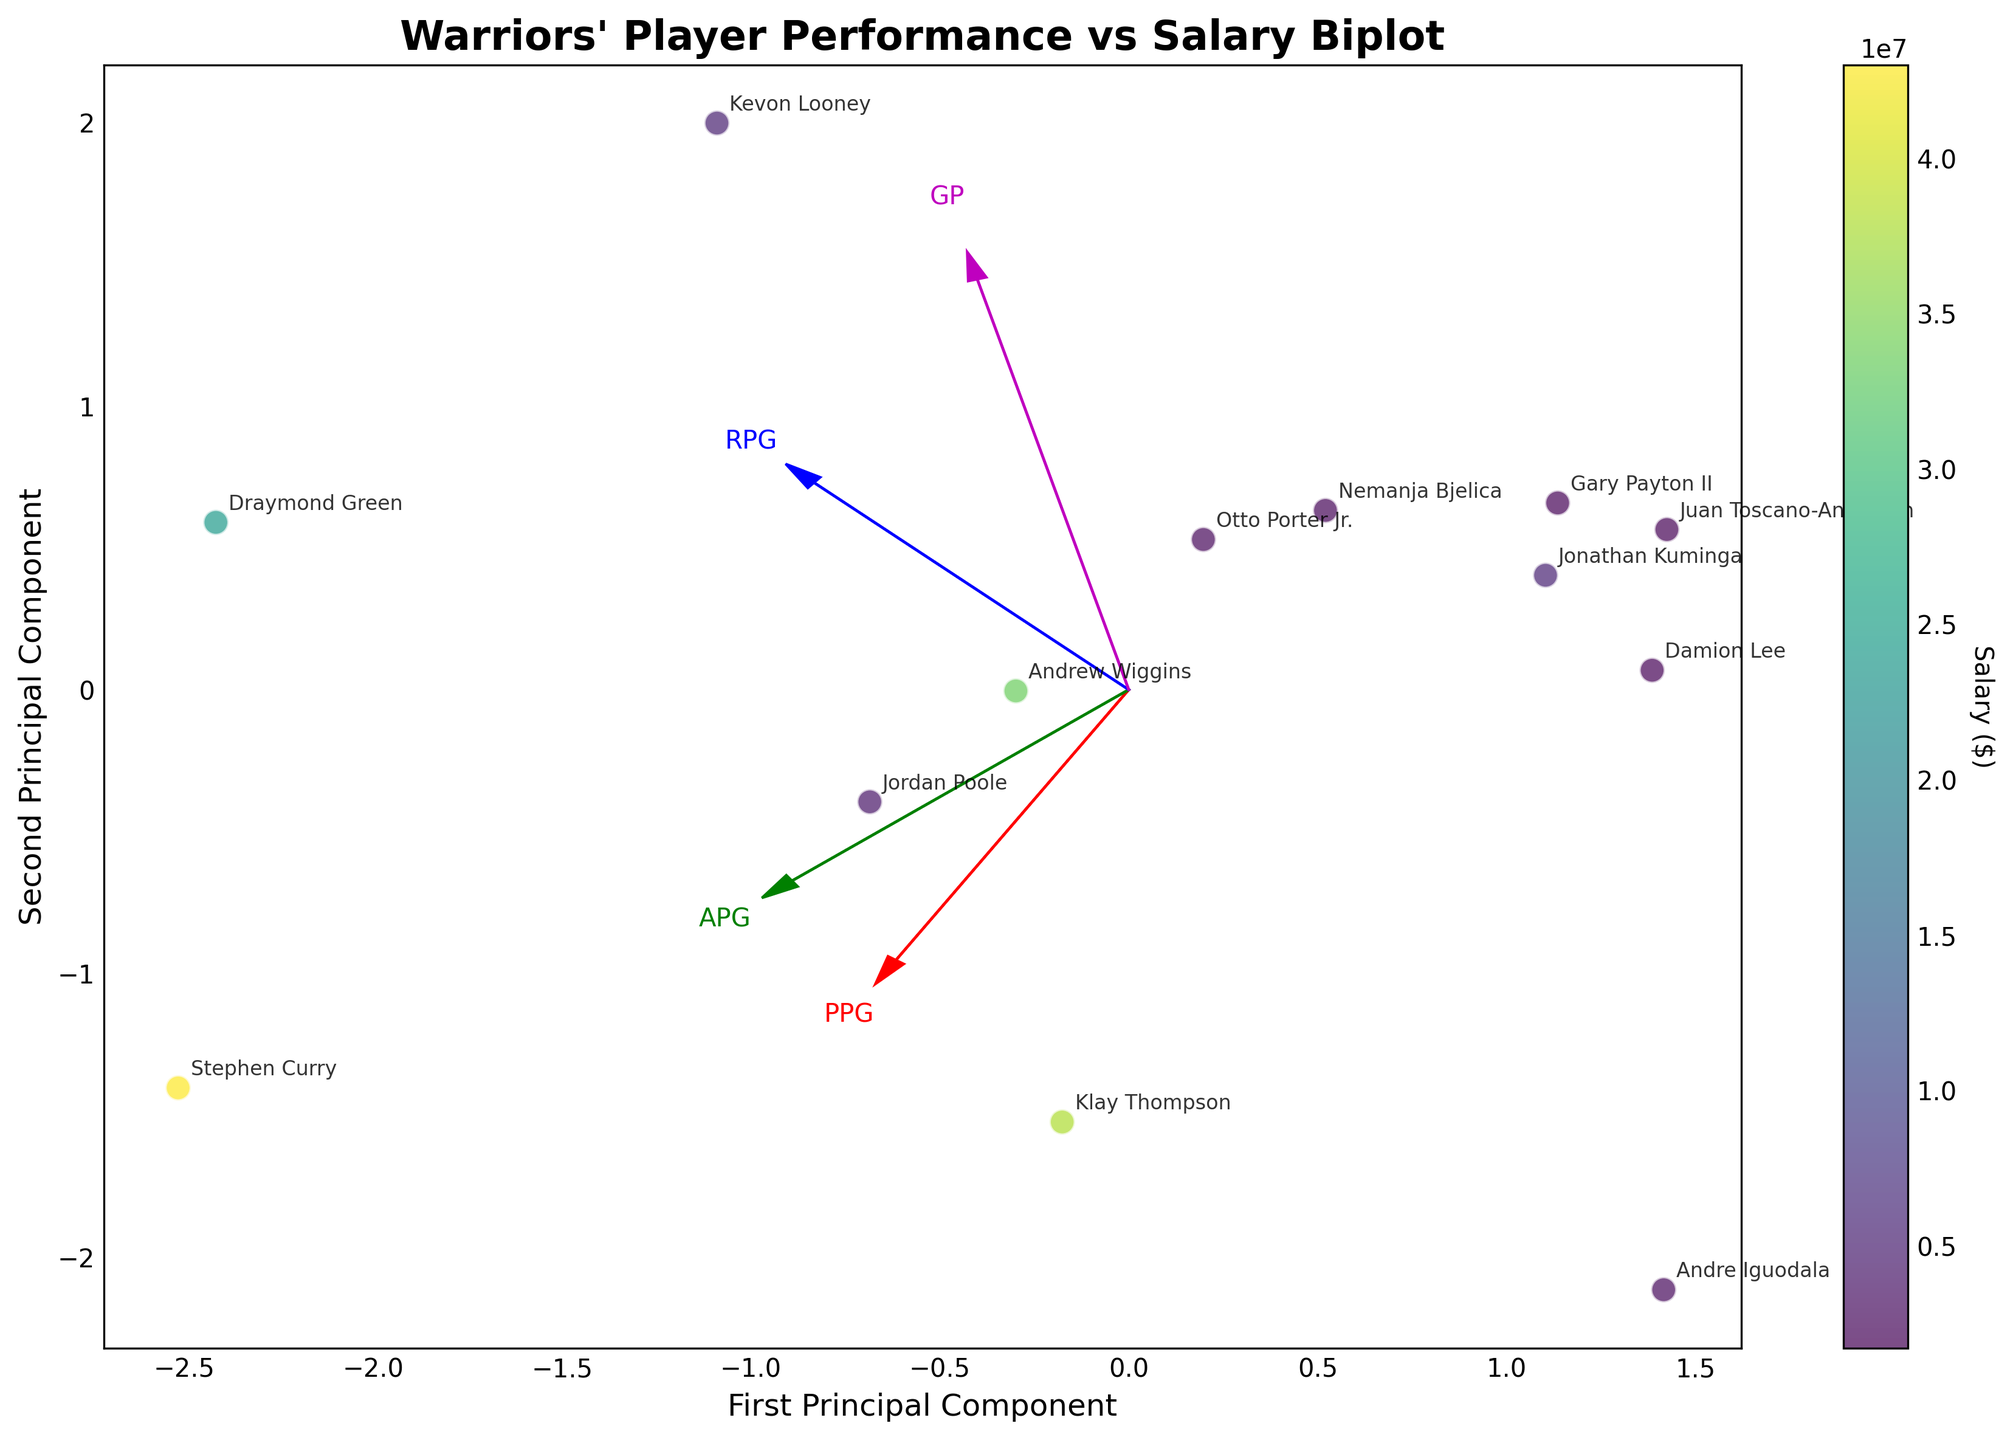What's the title of the plot? The title is displayed at the top of the plot and typically provides a short description of what the plot is about. In this case, it should be easy to see.
Answer: Warriors' Player Performance vs Salary Biplot How many principal components are shown in the plot? A biplot typically displays two principal components, which are usually shown on the x-axis and y-axis. The labels of the axes should indicate this.
Answer: Two Which player has the highest salary? The color of the data points represents the salary, with the color scale indicating higher values. Look for the point with the color corresponding to the highest salary.
Answer: Stephen Curry Which player has the highest value on the second principal component? Identify the point that is the furthest along the y-axis (second principal component) and use the label to determine the player.
Answer: Draymond Green What does the direction of the "Points_Per_Game" vector (PPG) suggest about players' performance concerning this metric? The direction of the PPG vector indicates how Points Per Game is aligned with the principal components. If the vector points in the general direction of many high-salary players, it suggests these players have high points per game.
Answer: High-scoring players tend to have high salaries Which feature contributes the most to the first principal component? Check which arrow (feature vector) points most closely to the x-axis (first principal component). The feature with the arrow most aligned with this axis contributes the most.
Answer: Points_Per_Game Are players with higher rebounds per game generally above or below the x-axis? The Rebounds_Per_Game (RPG) vector direction can help to determine the positioning. If the RPG vector points upwards, players with higher rebounds per game will lie more in the positive y direction.
Answer: Above Which player has the lowest value on the first principal component? Identify the point that is the furthest along the negative x-axis (first principal component) and use the label to determine the player.
Answer: Andre Iguodala Between Stephen Curry and Klay Thompson, who has played more games? Find the points labeled 'Stephen Curry' and 'Klay Thompson' and see which point is further in the direction of the Games Played vector (GP).
Answer: Stephen Curry 